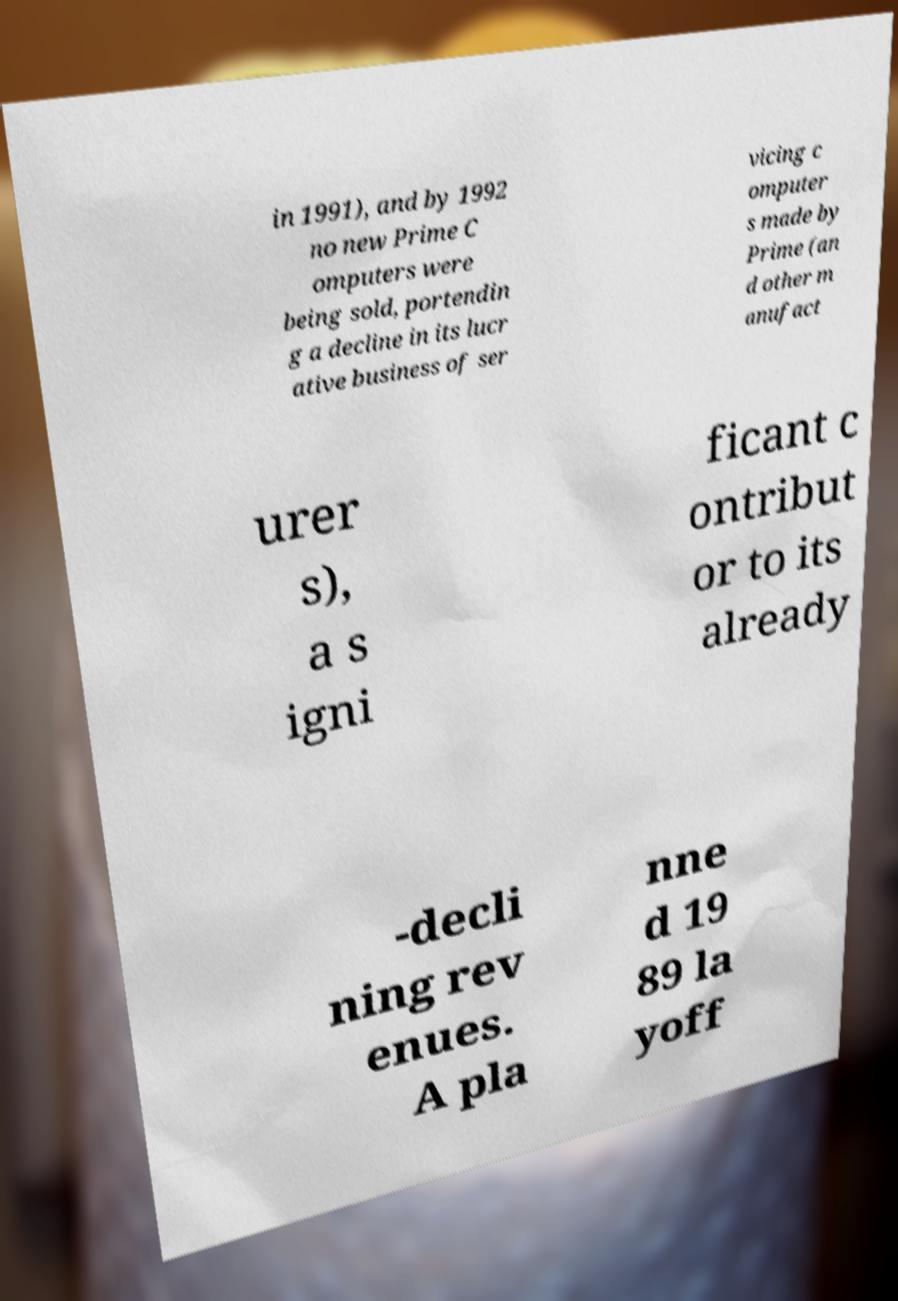Please identify and transcribe the text found in this image. in 1991), and by 1992 no new Prime C omputers were being sold, portendin g a decline in its lucr ative business of ser vicing c omputer s made by Prime (an d other m anufact urer s), a s igni ficant c ontribut or to its already -decli ning rev enues. A pla nne d 19 89 la yoff 